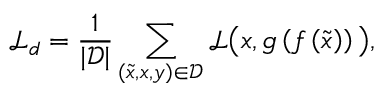Convert formula to latex. <formula><loc_0><loc_0><loc_500><loc_500>\mathcal { L } _ { d } = \frac { 1 } { | \mathcal { D } | } \sum _ { ( \tilde { x } , x , y ) \in \mathcal { D } } \mathcal { L } \left ( x , g \left ( f \left ( \tilde { x } \right ) \right ) \right ) ,</formula> 